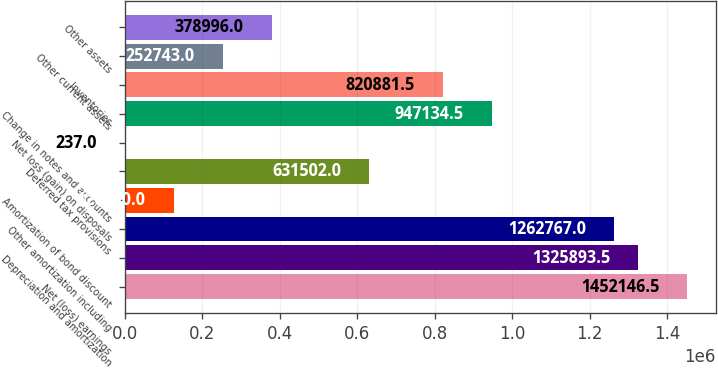<chart> <loc_0><loc_0><loc_500><loc_500><bar_chart><fcel>Net (loss) earnings<fcel>Depreciation and amortization<fcel>Other amortization including<fcel>Amortization of bond discount<fcel>Deferred tax provisions<fcel>Net loss (gain) on disposals<fcel>Change in notes and accounts<fcel>Inventories<fcel>Other current assets<fcel>Other assets<nl><fcel>1.45215e+06<fcel>1.32589e+06<fcel>1.26277e+06<fcel>126490<fcel>631502<fcel>237<fcel>947134<fcel>820882<fcel>252743<fcel>378996<nl></chart> 